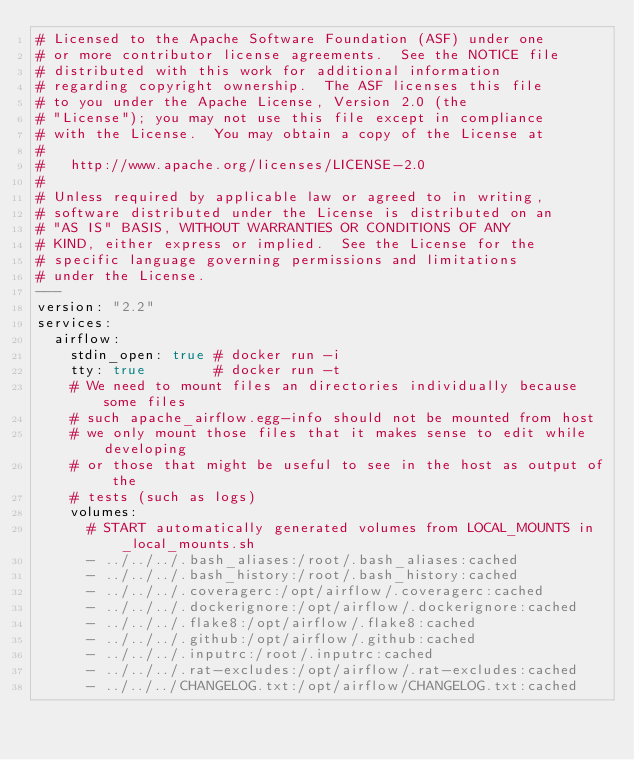Convert code to text. <code><loc_0><loc_0><loc_500><loc_500><_YAML_># Licensed to the Apache Software Foundation (ASF) under one
# or more contributor license agreements.  See the NOTICE file
# distributed with this work for additional information
# regarding copyright ownership.  The ASF licenses this file
# to you under the Apache License, Version 2.0 (the
# "License"); you may not use this file except in compliance
# with the License.  You may obtain a copy of the License at
#
#   http://www.apache.org/licenses/LICENSE-2.0
#
# Unless required by applicable law or agreed to in writing,
# software distributed under the License is distributed on an
# "AS IS" BASIS, WITHOUT WARRANTIES OR CONDITIONS OF ANY
# KIND, either express or implied.  See the License for the
# specific language governing permissions and limitations
# under the License.
---
version: "2.2"
services:
  airflow:
    stdin_open: true # docker run -i
    tty: true        # docker run -t
    # We need to mount files an directories individually because some files
    # such apache_airflow.egg-info should not be mounted from host
    # we only mount those files that it makes sense to edit while developing
    # or those that might be useful to see in the host as output of the
    # tests (such as logs)
    volumes:
      # START automatically generated volumes from LOCAL_MOUNTS in _local_mounts.sh
      - ../../../.bash_aliases:/root/.bash_aliases:cached
      - ../../../.bash_history:/root/.bash_history:cached
      - ../../../.coveragerc:/opt/airflow/.coveragerc:cached
      - ../../../.dockerignore:/opt/airflow/.dockerignore:cached
      - ../../../.flake8:/opt/airflow/.flake8:cached
      - ../../../.github:/opt/airflow/.github:cached
      - ../../../.inputrc:/root/.inputrc:cached
      - ../../../.rat-excludes:/opt/airflow/.rat-excludes:cached
      - ../../../CHANGELOG.txt:/opt/airflow/CHANGELOG.txt:cached</code> 